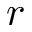Convert formula to latex. <formula><loc_0><loc_0><loc_500><loc_500>r</formula> 